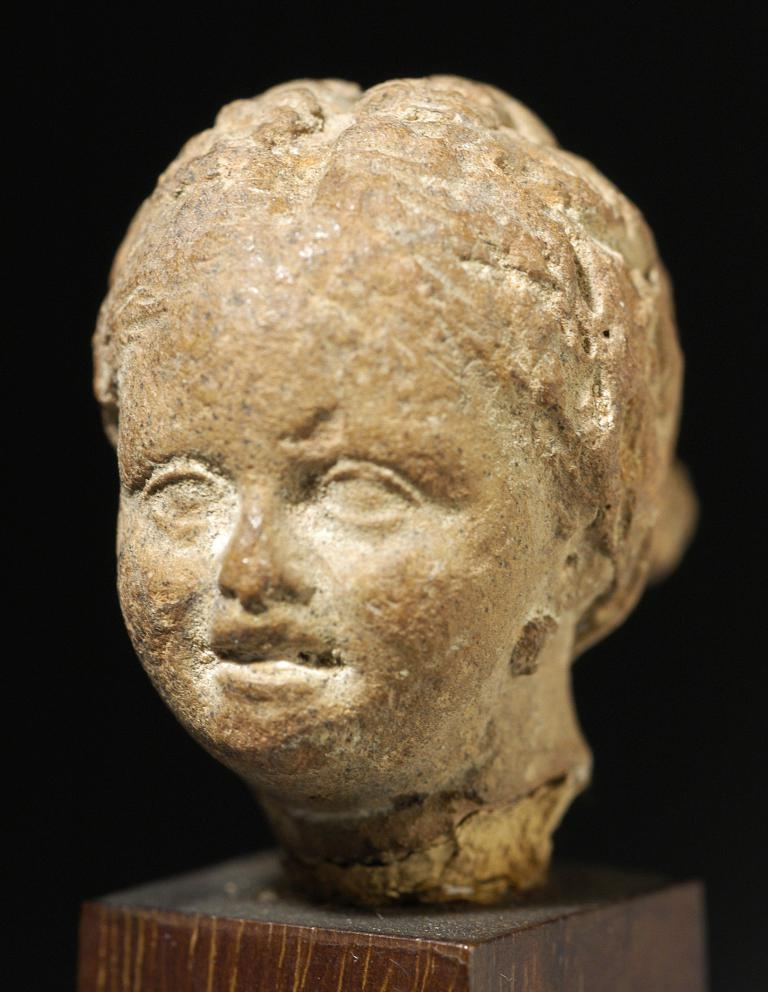What is the main subject of the image? There is a sculpture in the image. Where is the sculpture located? The sculpture is on a platform. Can you describe the background of the image? The background of the image is blurry. How many jellyfish can be seen swimming in the background of the image? There are no jellyfish present in the image; the background is blurry. 